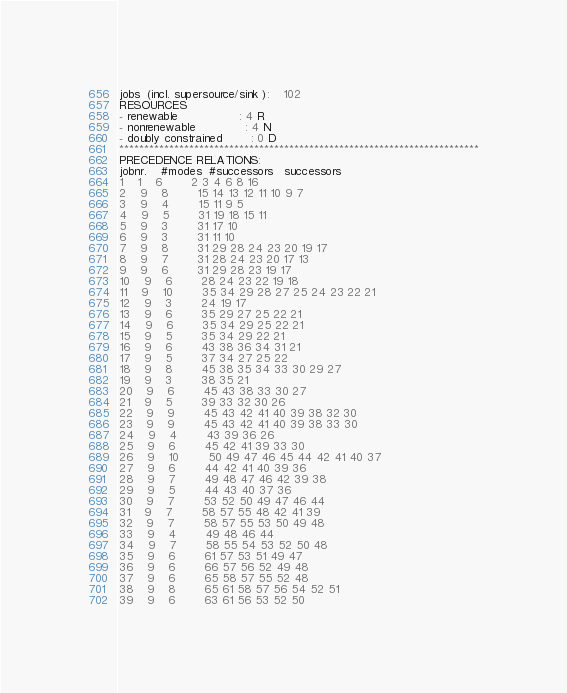<code> <loc_0><loc_0><loc_500><loc_500><_ObjectiveC_>jobs  (incl. supersource/sink ):	102
RESOURCES
- renewable                 : 4 R
- nonrenewable              : 4 N
- doubly constrained        : 0 D
************************************************************************
PRECEDENCE RELATIONS:
jobnr.    #modes  #successors   successors
1	1	6		2 3 4 6 8 16 
2	9	8		15 14 13 12 11 10 9 7 
3	9	4		15 11 9 5 
4	9	5		31 19 18 15 11 
5	9	3		31 17 10 
6	9	3		31 11 10 
7	9	8		31 29 28 24 23 20 19 17 
8	9	7		31 28 24 23 20 17 13 
9	9	6		31 29 28 23 19 17 
10	9	6		28 24 23 22 19 18 
11	9	10		35 34 29 28 27 25 24 23 22 21 
12	9	3		24 19 17 
13	9	6		35 29 27 25 22 21 
14	9	6		35 34 29 25 22 21 
15	9	5		35 34 29 22 21 
16	9	6		43 38 36 34 31 21 
17	9	5		37 34 27 25 22 
18	9	8		45 38 35 34 33 30 29 27 
19	9	3		38 35 21 
20	9	6		45 43 38 33 30 27 
21	9	5		39 33 32 30 26 
22	9	9		45 43 42 41 40 39 38 32 30 
23	9	9		45 43 42 41 40 39 38 33 30 
24	9	4		43 39 36 26 
25	9	6		45 42 41 39 33 30 
26	9	10		50 49 47 46 45 44 42 41 40 37 
27	9	6		44 42 41 40 39 36 
28	9	7		49 48 47 46 42 39 38 
29	9	5		44 43 40 37 36 
30	9	7		53 52 50 49 47 46 44 
31	9	7		58 57 55 48 42 41 39 
32	9	7		58 57 55 53 50 49 48 
33	9	4		49 48 46 44 
34	9	7		58 55 54 53 52 50 48 
35	9	6		61 57 53 51 49 47 
36	9	6		66 57 56 52 49 48 
37	9	6		65 58 57 55 52 48 
38	9	8		65 61 58 57 56 54 52 51 
39	9	6		63 61 56 53 52 50 </code> 